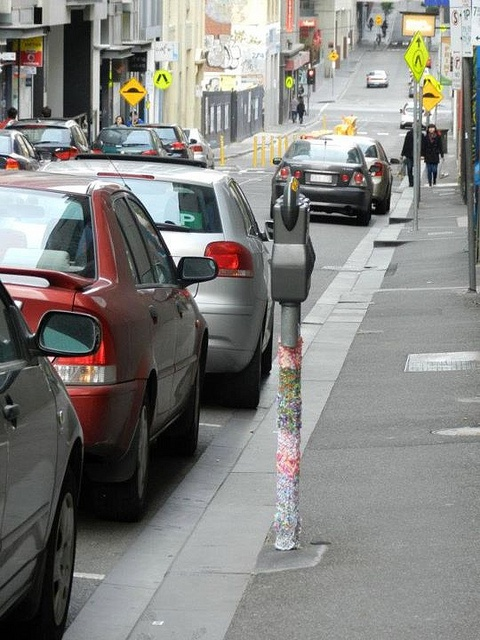Describe the objects in this image and their specific colors. I can see car in darkgray, black, gray, lightgray, and maroon tones, car in darkgray, gray, and black tones, car in darkgray, gray, lightgray, and black tones, car in darkgray, black, gray, and lightgray tones, and parking meter in darkgray, gray, black, and lightgray tones in this image. 